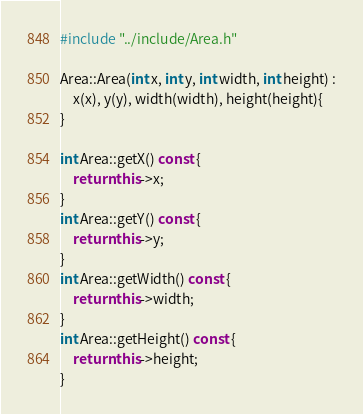<code> <loc_0><loc_0><loc_500><loc_500><_C++_>#include "../include/Area.h"

Area::Area(int x, int y, int width, int height) :
	x(x), y(y), width(width), height(height){
}
	
int Area::getX() const {
	return this->x;
}
int Area::getY() const {
	return this->y;
}
int Area::getWidth() const {
	return this->width;
}
int Area::getHeight() const {
	return this->height;
}</code> 